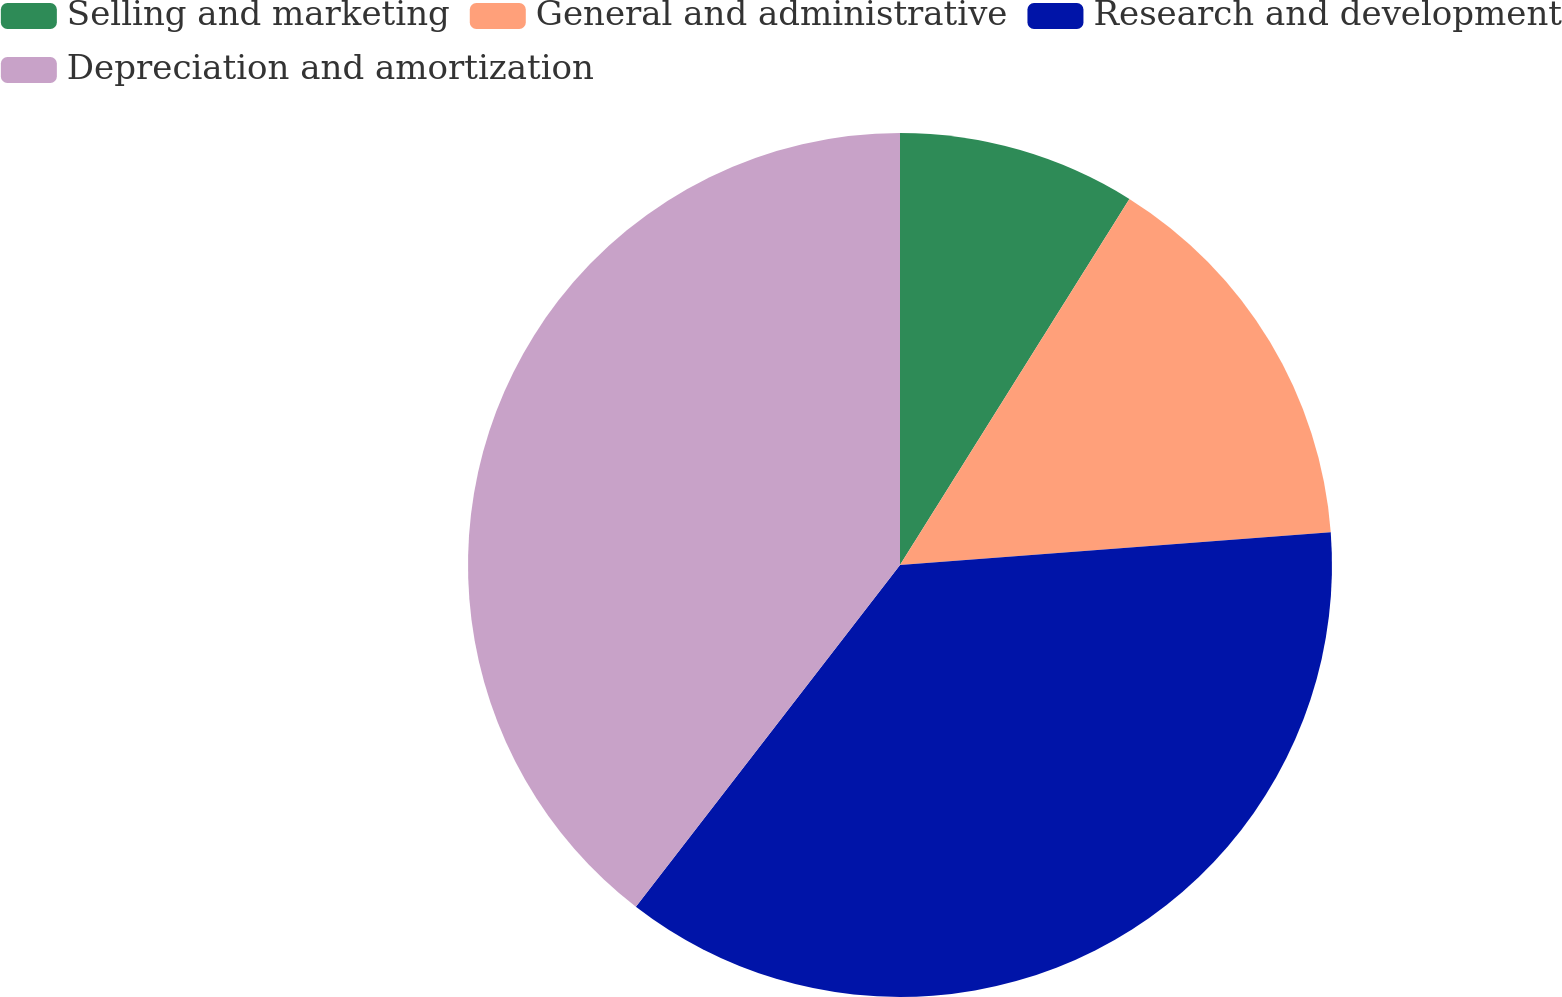Convert chart to OTSL. <chart><loc_0><loc_0><loc_500><loc_500><pie_chart><fcel>Selling and marketing<fcel>General and administrative<fcel>Research and development<fcel>Depreciation and amortization<nl><fcel>8.91%<fcel>14.88%<fcel>36.68%<fcel>39.53%<nl></chart> 